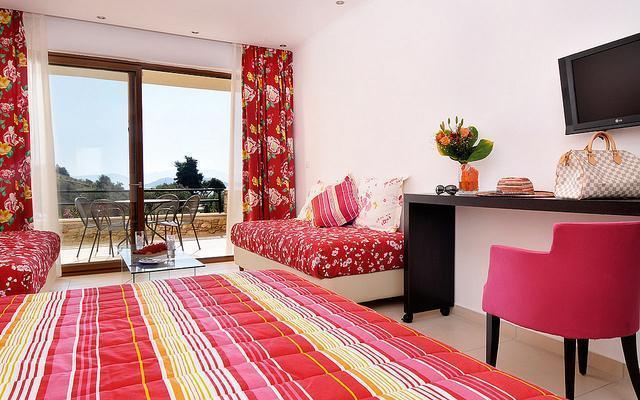How many beds are in the photo?
Give a very brief answer. 3. How many elephants are holding their trunks up in the picture?
Give a very brief answer. 0. 